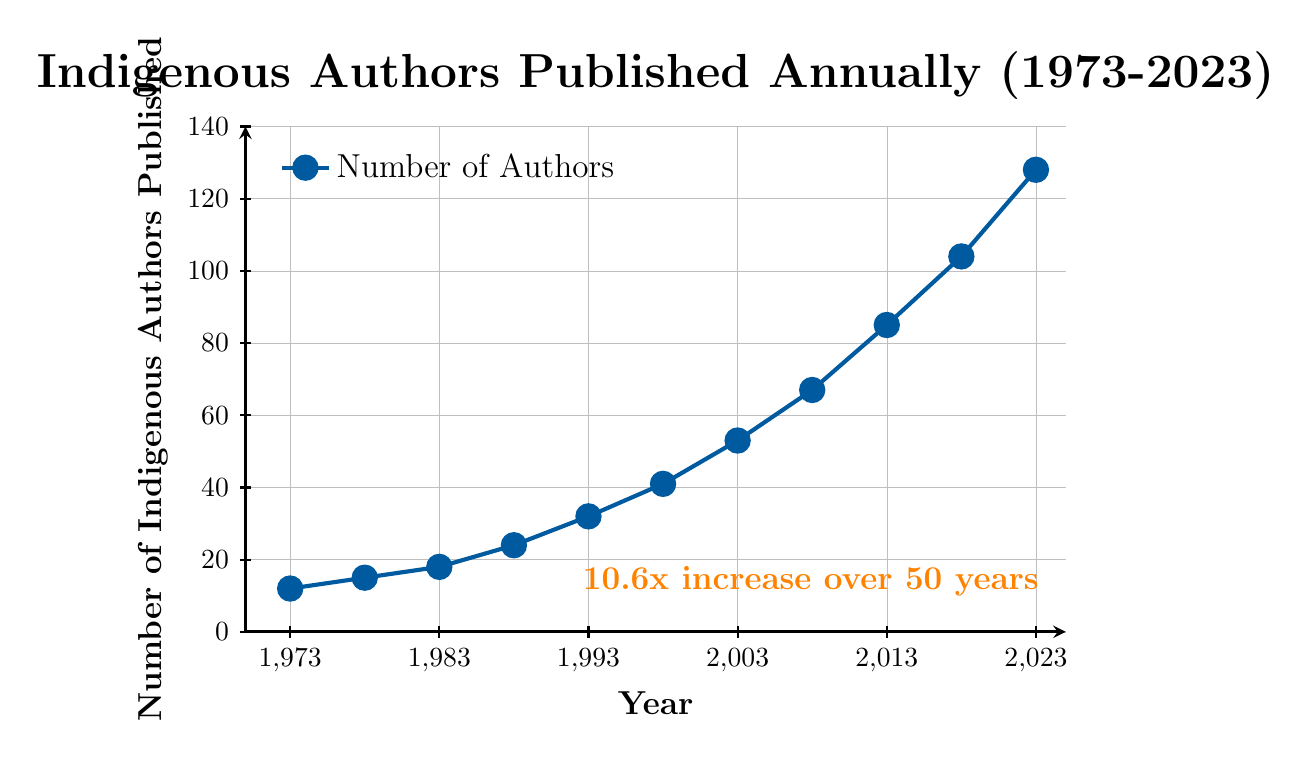When did the number of Indigenous authors first exceed 50? The figure shows the number of Indigenous authors published annually. We see that the count first exceeds 50 around the year 2003, where the number is 53.
Answer: 2003 What is the highest number of Indigenous authors published in any year? The chart's y-axis marks the number of Indigenous authors, peaking at 128 in the year 2023, which is the highest number in the depicted period.
Answer: 128 How much did the number of Indigenous authors increase from 1988 to 2023? In 1988, 24 authors were published, and by 2023, 128 authors were published. The increase is 128 - 24 = 104 authors.
Answer: 104 What is the average annual increase in the number of Indigenous authors from 1973 to 2023? Over the 50 years from 1973 to 2023, the number increased from 12 to 128. Thus, the total increase is 128 - 12 = 116 authors. The average annual increase is 116 / 50 = 2.32 authors per year.
Answer: 2.32 Which decade saw the largest increase in the number of Indigenous authors published? Comparing the increases: 
1973-1983: 18-12=6
1983-1993: 32-18=14
1993-2003: 53-32=21
2003-2013: 85-53=32
2013-2023: 128-85=43
The decade 2013-2023 saw the largest increase of 43 authors.
Answer: 2013-2023 By how much did the number of Indigenous authors grow between 1978 and 1988? In 1978, 15 authors were published, and in 1988, 24 authors were published. Thus, the growth is 24 - 15 = 9 authors.
Answer: 9 Was there any period in which the number of Indigenous authors did not increase? The figure shows a continuous increase in the number of Indigenous authors annually from 1973 to 2023 without any period of stagnation or decrease.
Answer: No By what factor did the number of Indigenous authors increase from 1973 to 2023? The number of authors in 1973 was 12, and in 2023 it was 128. Thus, the factor increase is 128 / 12 ≈ 10.67.
Answer: 10.67 What is the trend in the number of Indigenous authors published from 2008 to 2018? From 2008 to 2018, the number of Indigenous authors increased from 67 to 104. This shows a consistent upward trend.
Answer: Upward Which color is used to represent the number of Indigenous authors published? The line representing the number of Indigenous authors published is depicted in blue.
Answer: Blue 